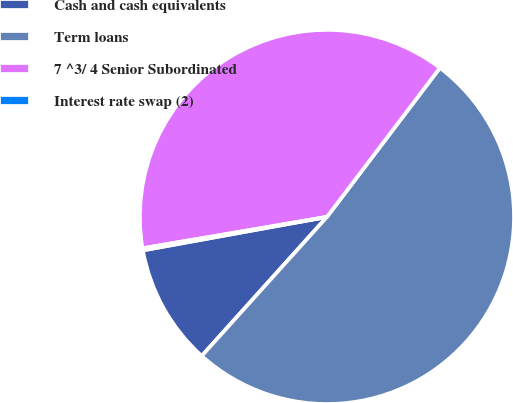<chart> <loc_0><loc_0><loc_500><loc_500><pie_chart><fcel>Cash and cash equivalents<fcel>Term loans<fcel>7 ^3/ 4 Senior Subordinated<fcel>Interest rate swap (2)<nl><fcel>10.47%<fcel>51.35%<fcel>38.0%<fcel>0.18%<nl></chart> 